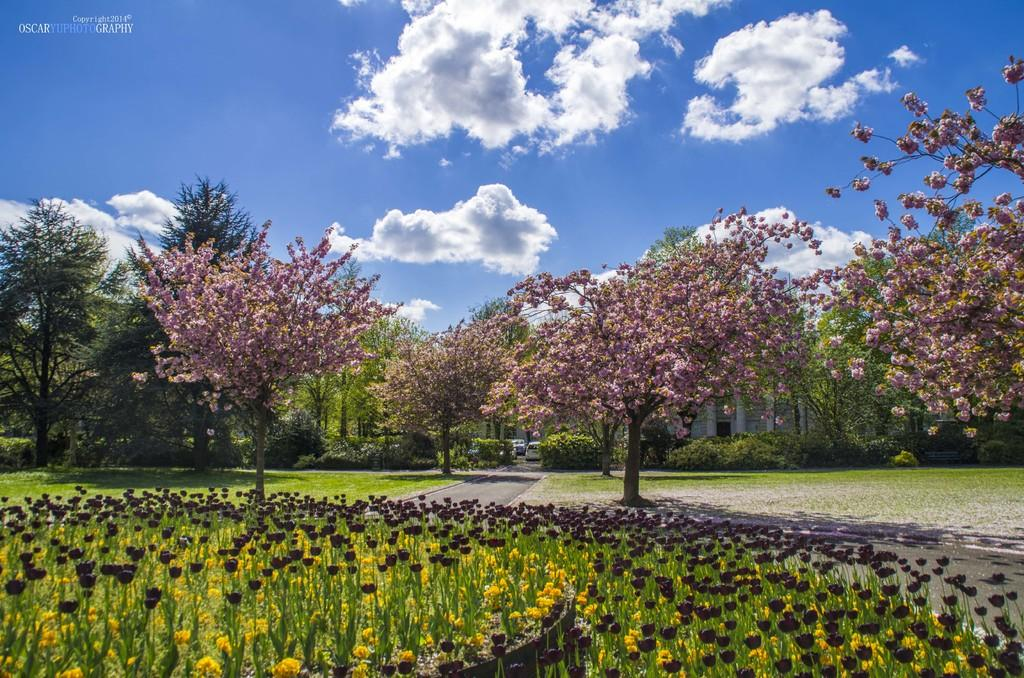What is the main subject of the image? The image contains a picture. What can be seen in the sky of the picture? The sky in the picture includes clouds. What type of natural elements are present in the picture? There are trees visible in the picture. What type of man-made structures are present in the picture? There are buildings in the picture. What type of transportation is present in the picture? Motor vehicles are present in the picture. What type of pathway is visible in the picture? There is a road in the picture. What type of vegetation is visible in the picture besides trees? Bushes are visible in the picture. What type of surface is visible at the bottom of the picture? The ground is visible in the picture. What type of insurance policy is being advertised on the trees in the picture? There is no insurance policy or advertisement present on the trees in the picture; they are simply trees. 